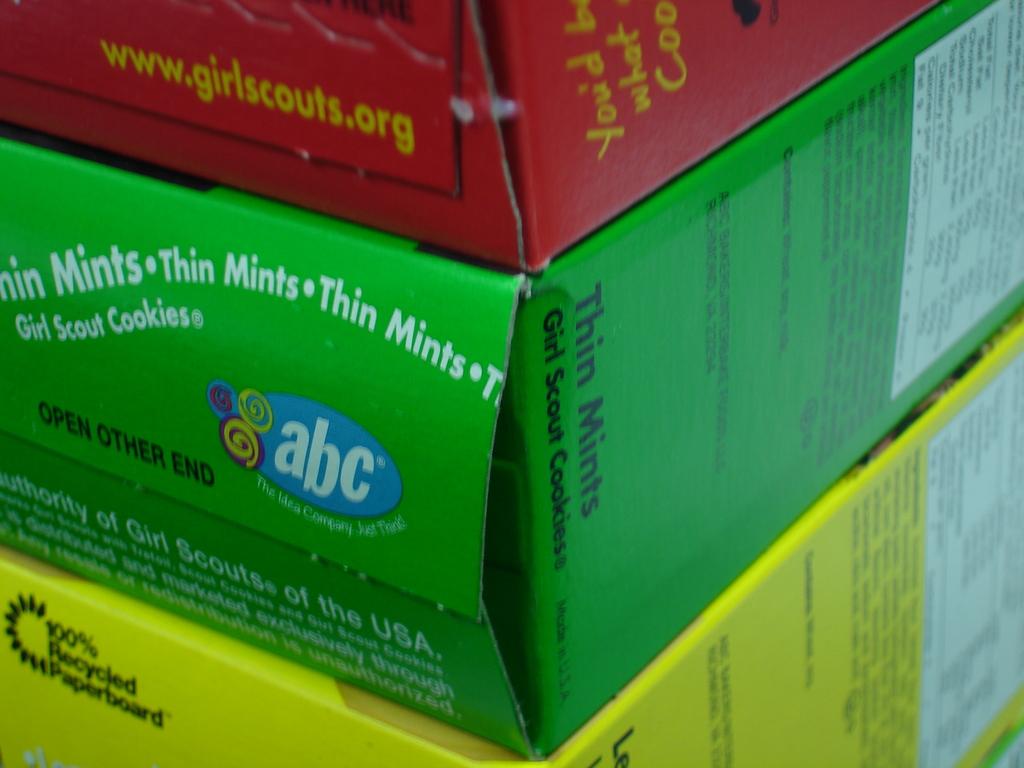What flavor cookie is the green box?
Provide a succinct answer. Thin mints. Who sells these cookies?
Your response must be concise. Girl scouts. 